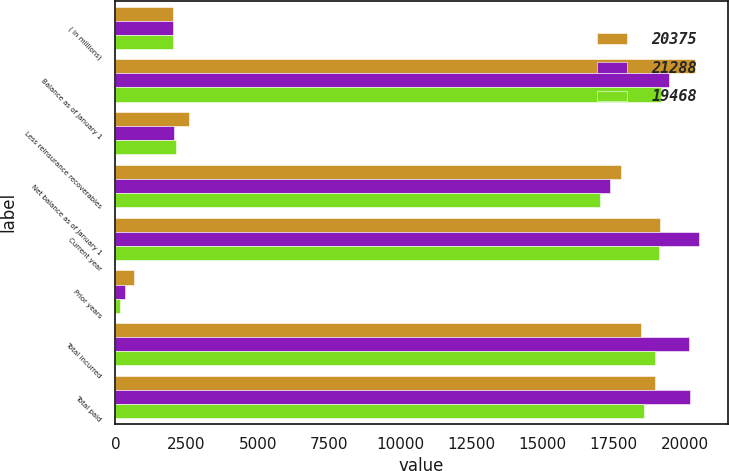Convert chart to OTSL. <chart><loc_0><loc_0><loc_500><loc_500><stacked_bar_chart><ecel><fcel>( in millions)<fcel>Balance as of January 1<fcel>Less reinsurance recoverables<fcel>Net balance as of January 1<fcel>Current year<fcel>Prior years<fcel>Total incurred<fcel>Total paid<nl><fcel>20375<fcel>2012<fcel>20375<fcel>2588<fcel>17787<fcel>19149<fcel>665<fcel>18484<fcel>18980<nl><fcel>21288<fcel>2011<fcel>19468<fcel>2072<fcel>17396<fcel>20496<fcel>335<fcel>20161<fcel>20195<nl><fcel>19468<fcel>2010<fcel>19167<fcel>2139<fcel>17028<fcel>19110<fcel>159<fcel>18951<fcel>18583<nl></chart> 